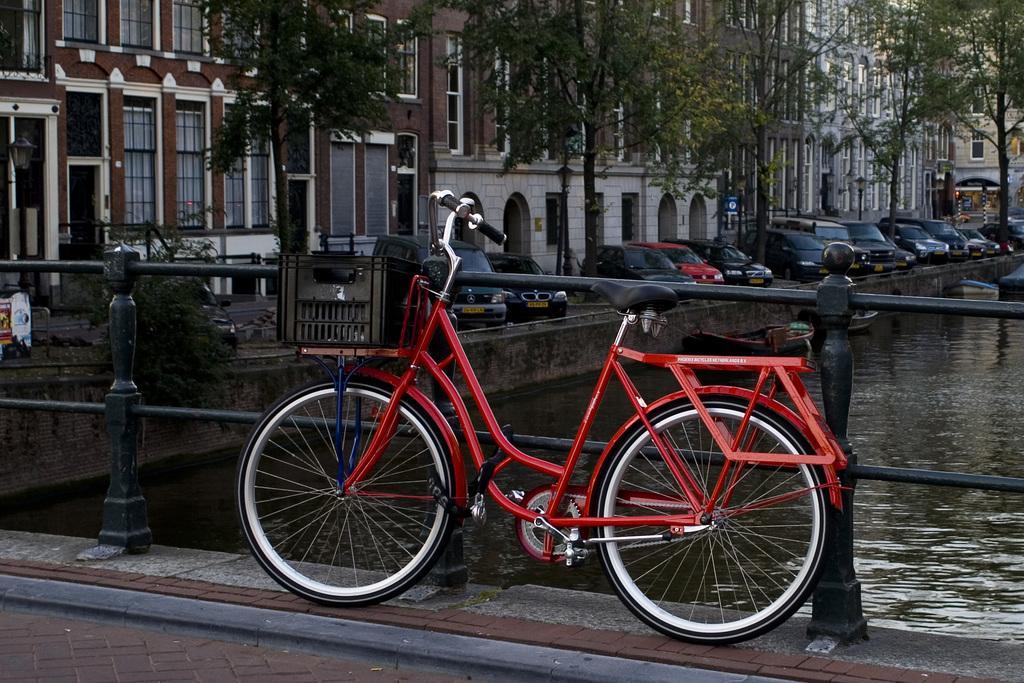Please provide a concise description of this image. In the background we can see the buildings. In this picture we can see the windows, poles, board and few objects. We can see the cars, railing, bicycle, boats and the water. 